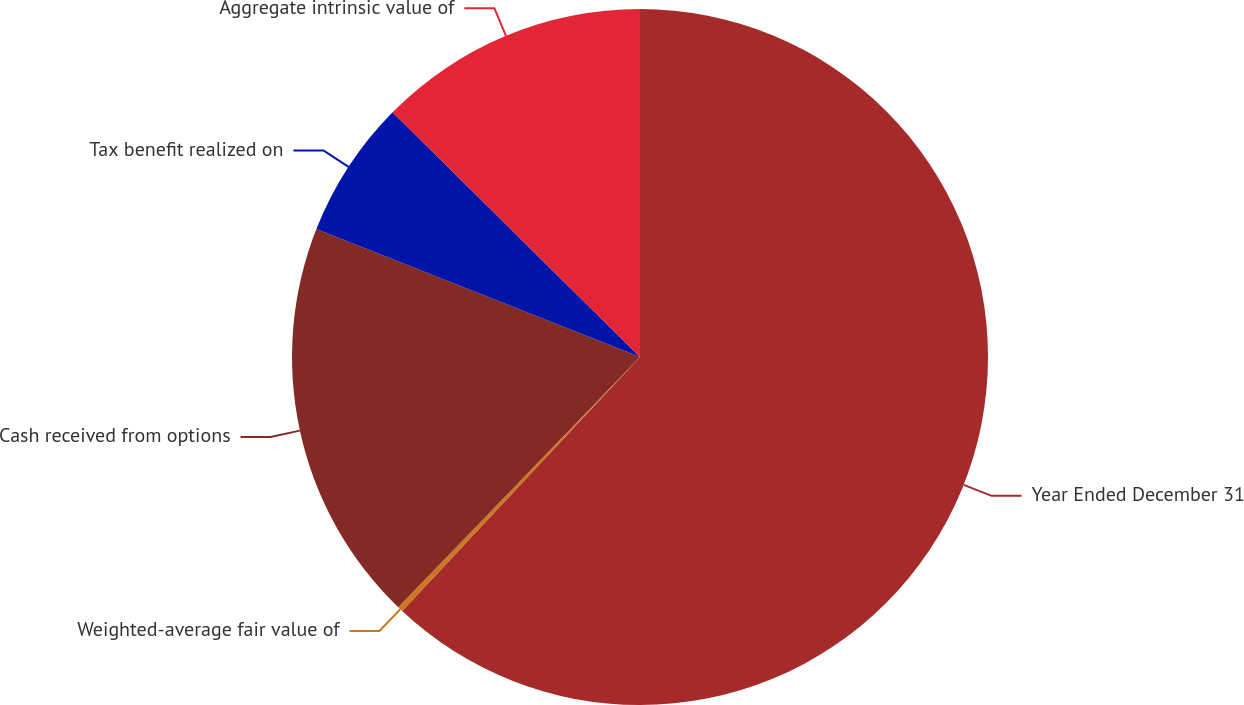<chart> <loc_0><loc_0><loc_500><loc_500><pie_chart><fcel>Year Ended December 31<fcel>Weighted-average fair value of<fcel>Cash received from options<fcel>Tax benefit realized on<fcel>Aggregate intrinsic value of<nl><fcel>61.98%<fcel>0.25%<fcel>18.77%<fcel>6.42%<fcel>12.59%<nl></chart> 